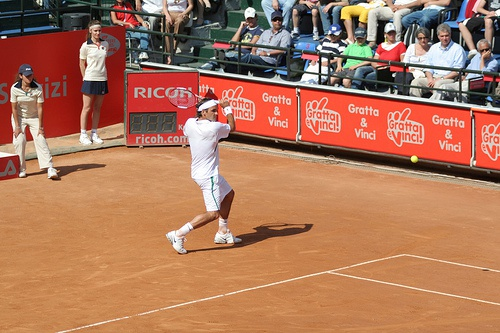Describe the objects in this image and their specific colors. I can see people in gray, black, red, and lightgray tones, people in gray, white, darkgray, maroon, and brown tones, people in gray, ivory, and darkgray tones, people in gray, ivory, maroon, black, and tan tones, and people in gray, white, darkgray, and tan tones in this image. 